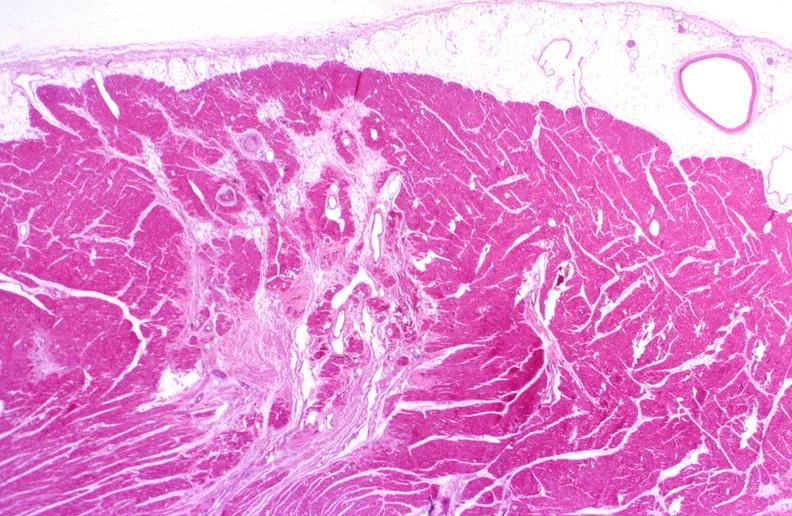where is this from?
Answer the question using a single word or phrase. Heart 